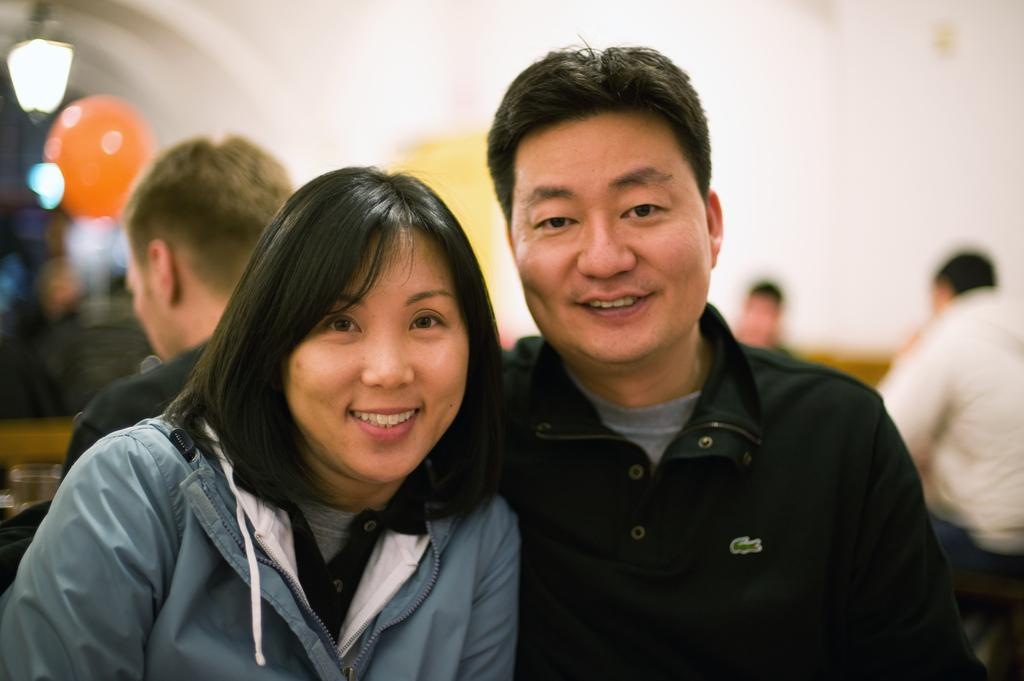How many people are present in the image? There is a man and a woman in the image, making a total of two people. What can be seen in the background of the image? There are people in the background of the image. How would you describe the background of the image? The background of the image is blurry. What type of metal is being used to make the selection in the image? A: There is no mention of a selection or metal in the image, so this question cannot be answered. 